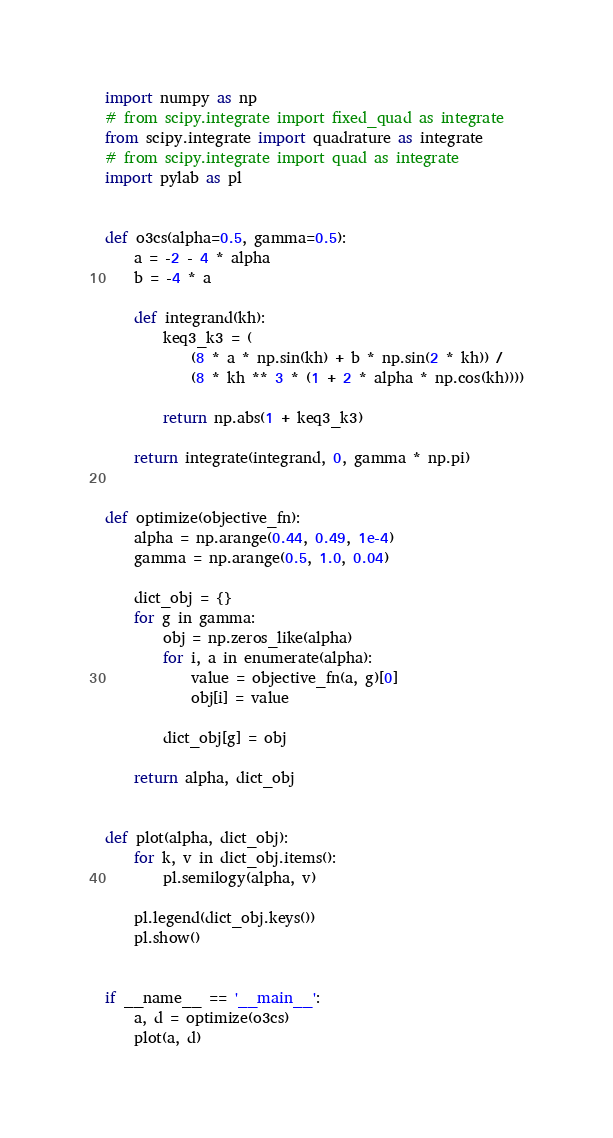<code> <loc_0><loc_0><loc_500><loc_500><_Python_>import numpy as np
# from scipy.integrate import fixed_quad as integrate
from scipy.integrate import quadrature as integrate
# from scipy.integrate import quad as integrate
import pylab as pl


def o3cs(alpha=0.5, gamma=0.5):
    a = -2 - 4 * alpha
    b = -4 * a

    def integrand(kh):
        keq3_k3 = (
            (8 * a * np.sin(kh) + b * np.sin(2 * kh)) /
            (8 * kh ** 3 * (1 + 2 * alpha * np.cos(kh))))

        return np.abs(1 + keq3_k3)

    return integrate(integrand, 0, gamma * np.pi)


def optimize(objective_fn):
    alpha = np.arange(0.44, 0.49, 1e-4)
    gamma = np.arange(0.5, 1.0, 0.04)

    dict_obj = {}
    for g in gamma:
        obj = np.zeros_like(alpha)
        for i, a in enumerate(alpha):
            value = objective_fn(a, g)[0]
            obj[i] = value

        dict_obj[g] = obj

    return alpha, dict_obj


def plot(alpha, dict_obj):
    for k, v in dict_obj.items():
        pl.semilogy(alpha, v)

    pl.legend(dict_obj.keys())
    pl.show()


if __name__ == '__main__':
    a, d = optimize(o3cs)
    plot(a, d)
</code> 